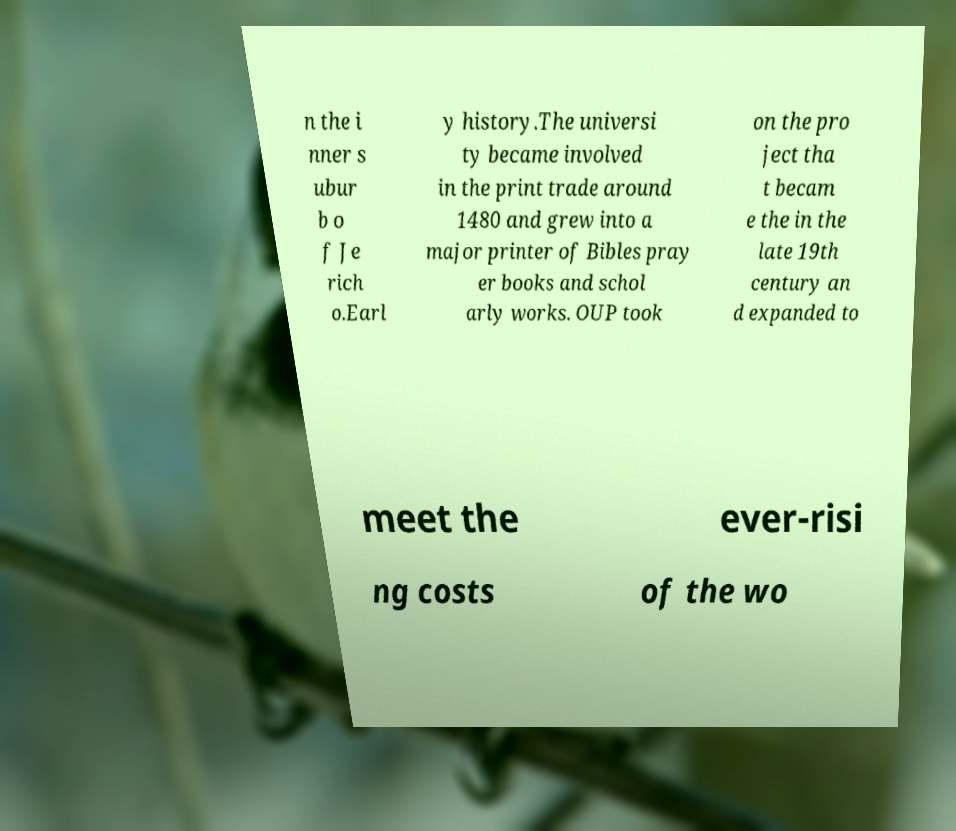Could you assist in decoding the text presented in this image and type it out clearly? n the i nner s ubur b o f Je rich o.Earl y history.The universi ty became involved in the print trade around 1480 and grew into a major printer of Bibles pray er books and schol arly works. OUP took on the pro ject tha t becam e the in the late 19th century an d expanded to meet the ever-risi ng costs of the wo 